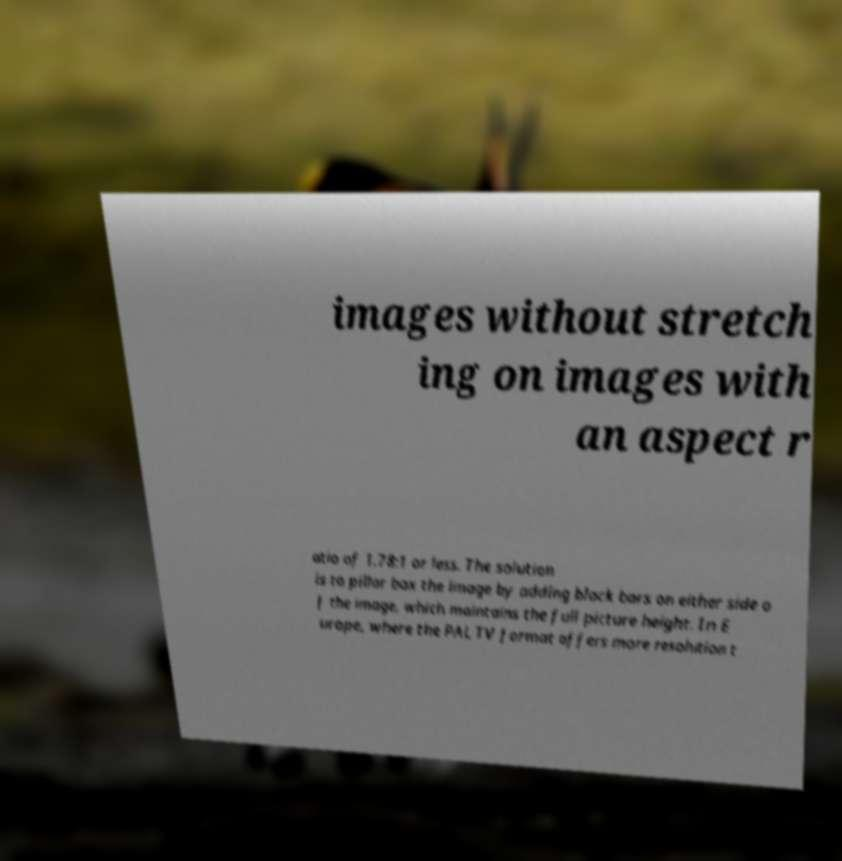There's text embedded in this image that I need extracted. Can you transcribe it verbatim? images without stretch ing on images with an aspect r atio of 1.78:1 or less. The solution is to pillar box the image by adding black bars on either side o f the image, which maintains the full picture height. In E urope, where the PAL TV format offers more resolution t 